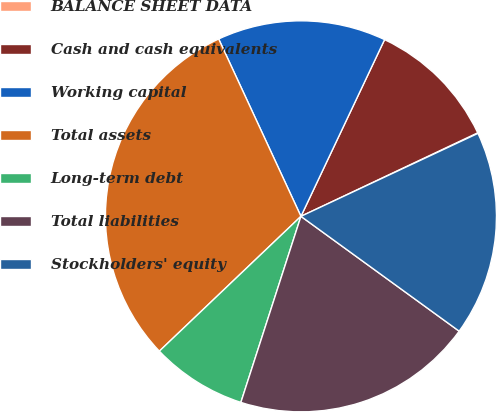Convert chart. <chart><loc_0><loc_0><loc_500><loc_500><pie_chart><fcel>BALANCE SHEET DATA<fcel>Cash and cash equivalents<fcel>Working capital<fcel>Total assets<fcel>Long-term debt<fcel>Total liabilities<fcel>Stockholders' equity<nl><fcel>0.05%<fcel>10.94%<fcel>13.95%<fcel>30.2%<fcel>7.92%<fcel>19.98%<fcel>16.97%<nl></chart> 